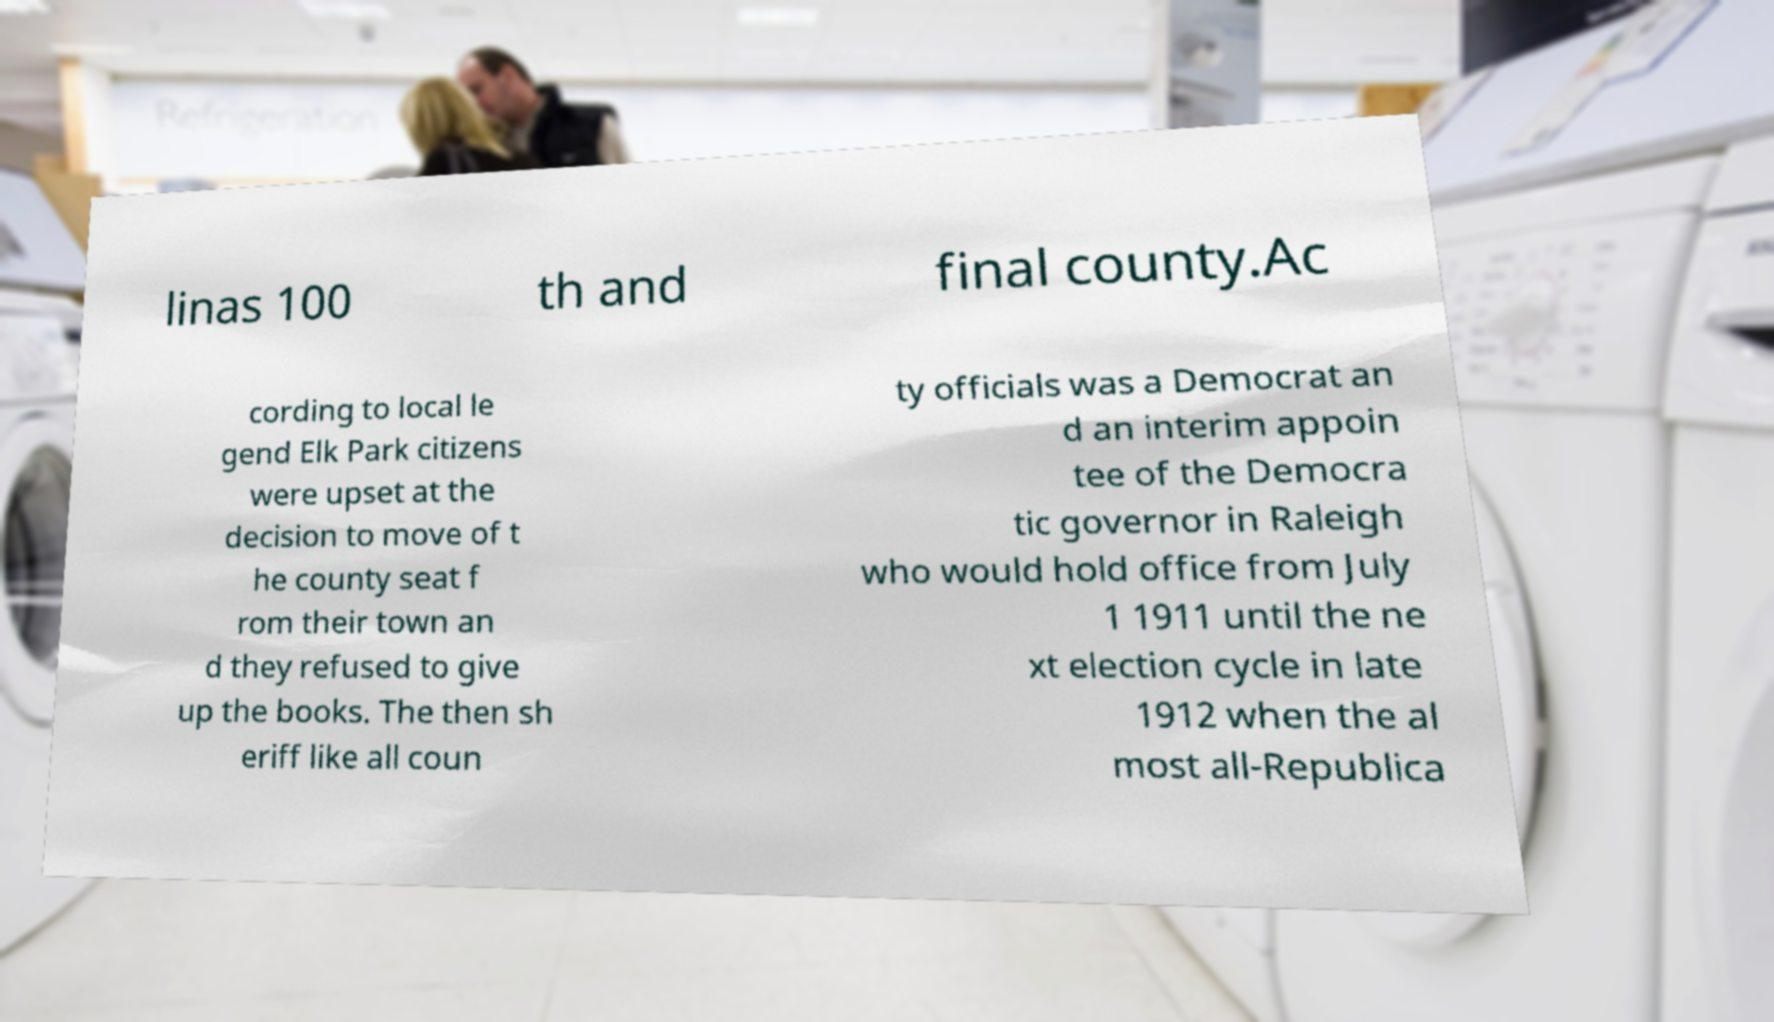Can you accurately transcribe the text from the provided image for me? linas 100 th and final county.Ac cording to local le gend Elk Park citizens were upset at the decision to move of t he county seat f rom their town an d they refused to give up the books. The then sh eriff like all coun ty officials was a Democrat an d an interim appoin tee of the Democra tic governor in Raleigh who would hold office from July 1 1911 until the ne xt election cycle in late 1912 when the al most all-Republica 